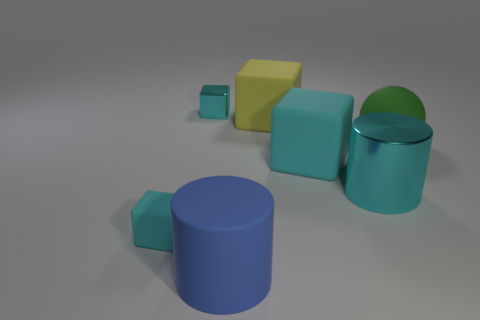Subtract all large cyan cubes. How many cubes are left? 3 Subtract all blue cylinders. How many cylinders are left? 1 Subtract all cylinders. How many objects are left? 5 Add 1 brown spheres. How many objects exist? 8 Subtract 1 cylinders. How many cylinders are left? 1 Subtract all cyan spheres. Subtract all cyan cylinders. How many spheres are left? 1 Subtract all green cubes. How many brown cylinders are left? 0 Subtract all large cyan matte things. Subtract all big metal cylinders. How many objects are left? 5 Add 2 green spheres. How many green spheres are left? 3 Add 4 big cyan metal things. How many big cyan metal things exist? 5 